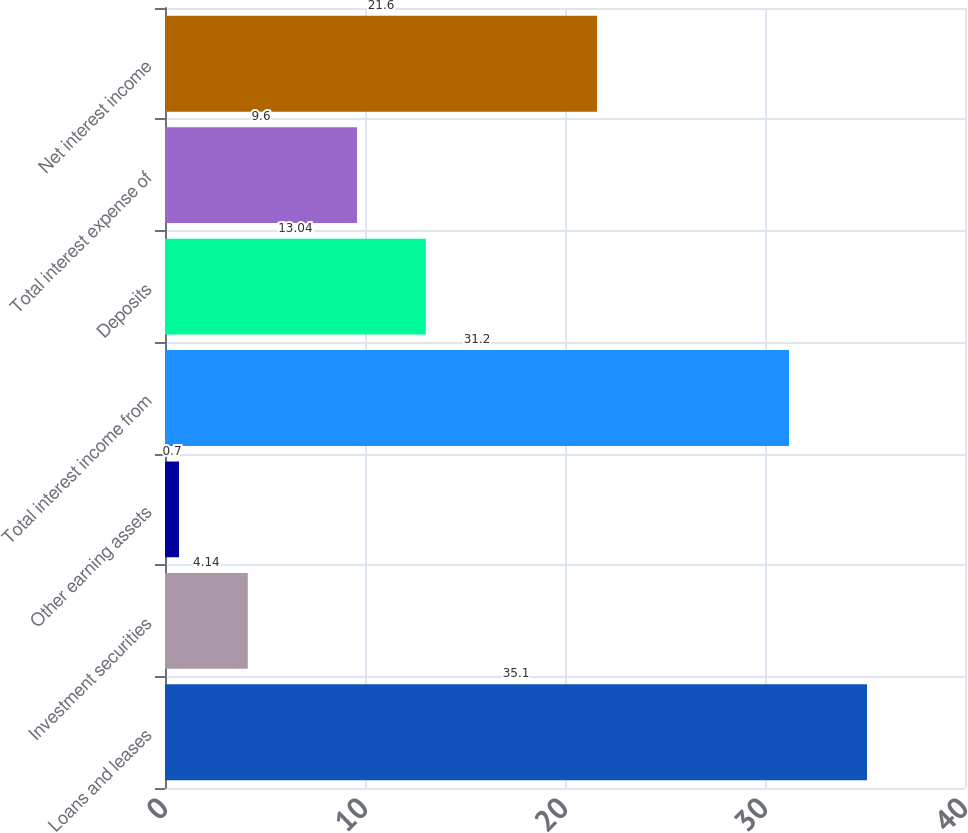Convert chart to OTSL. <chart><loc_0><loc_0><loc_500><loc_500><bar_chart><fcel>Loans and leases<fcel>Investment securities<fcel>Other earning assets<fcel>Total interest income from<fcel>Deposits<fcel>Total interest expense of<fcel>Net interest income<nl><fcel>35.1<fcel>4.14<fcel>0.7<fcel>31.2<fcel>13.04<fcel>9.6<fcel>21.6<nl></chart> 